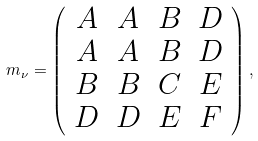<formula> <loc_0><loc_0><loc_500><loc_500>m _ { \nu } = \left ( \begin{array} { c c c c } { A } & { A } & { B } & { D } \\ { A } & { A } & { B } & { D } \\ { B } & { B } & { C } & { E } \\ { D } & { D } & { E } & { F } \end{array} \right ) ,</formula> 